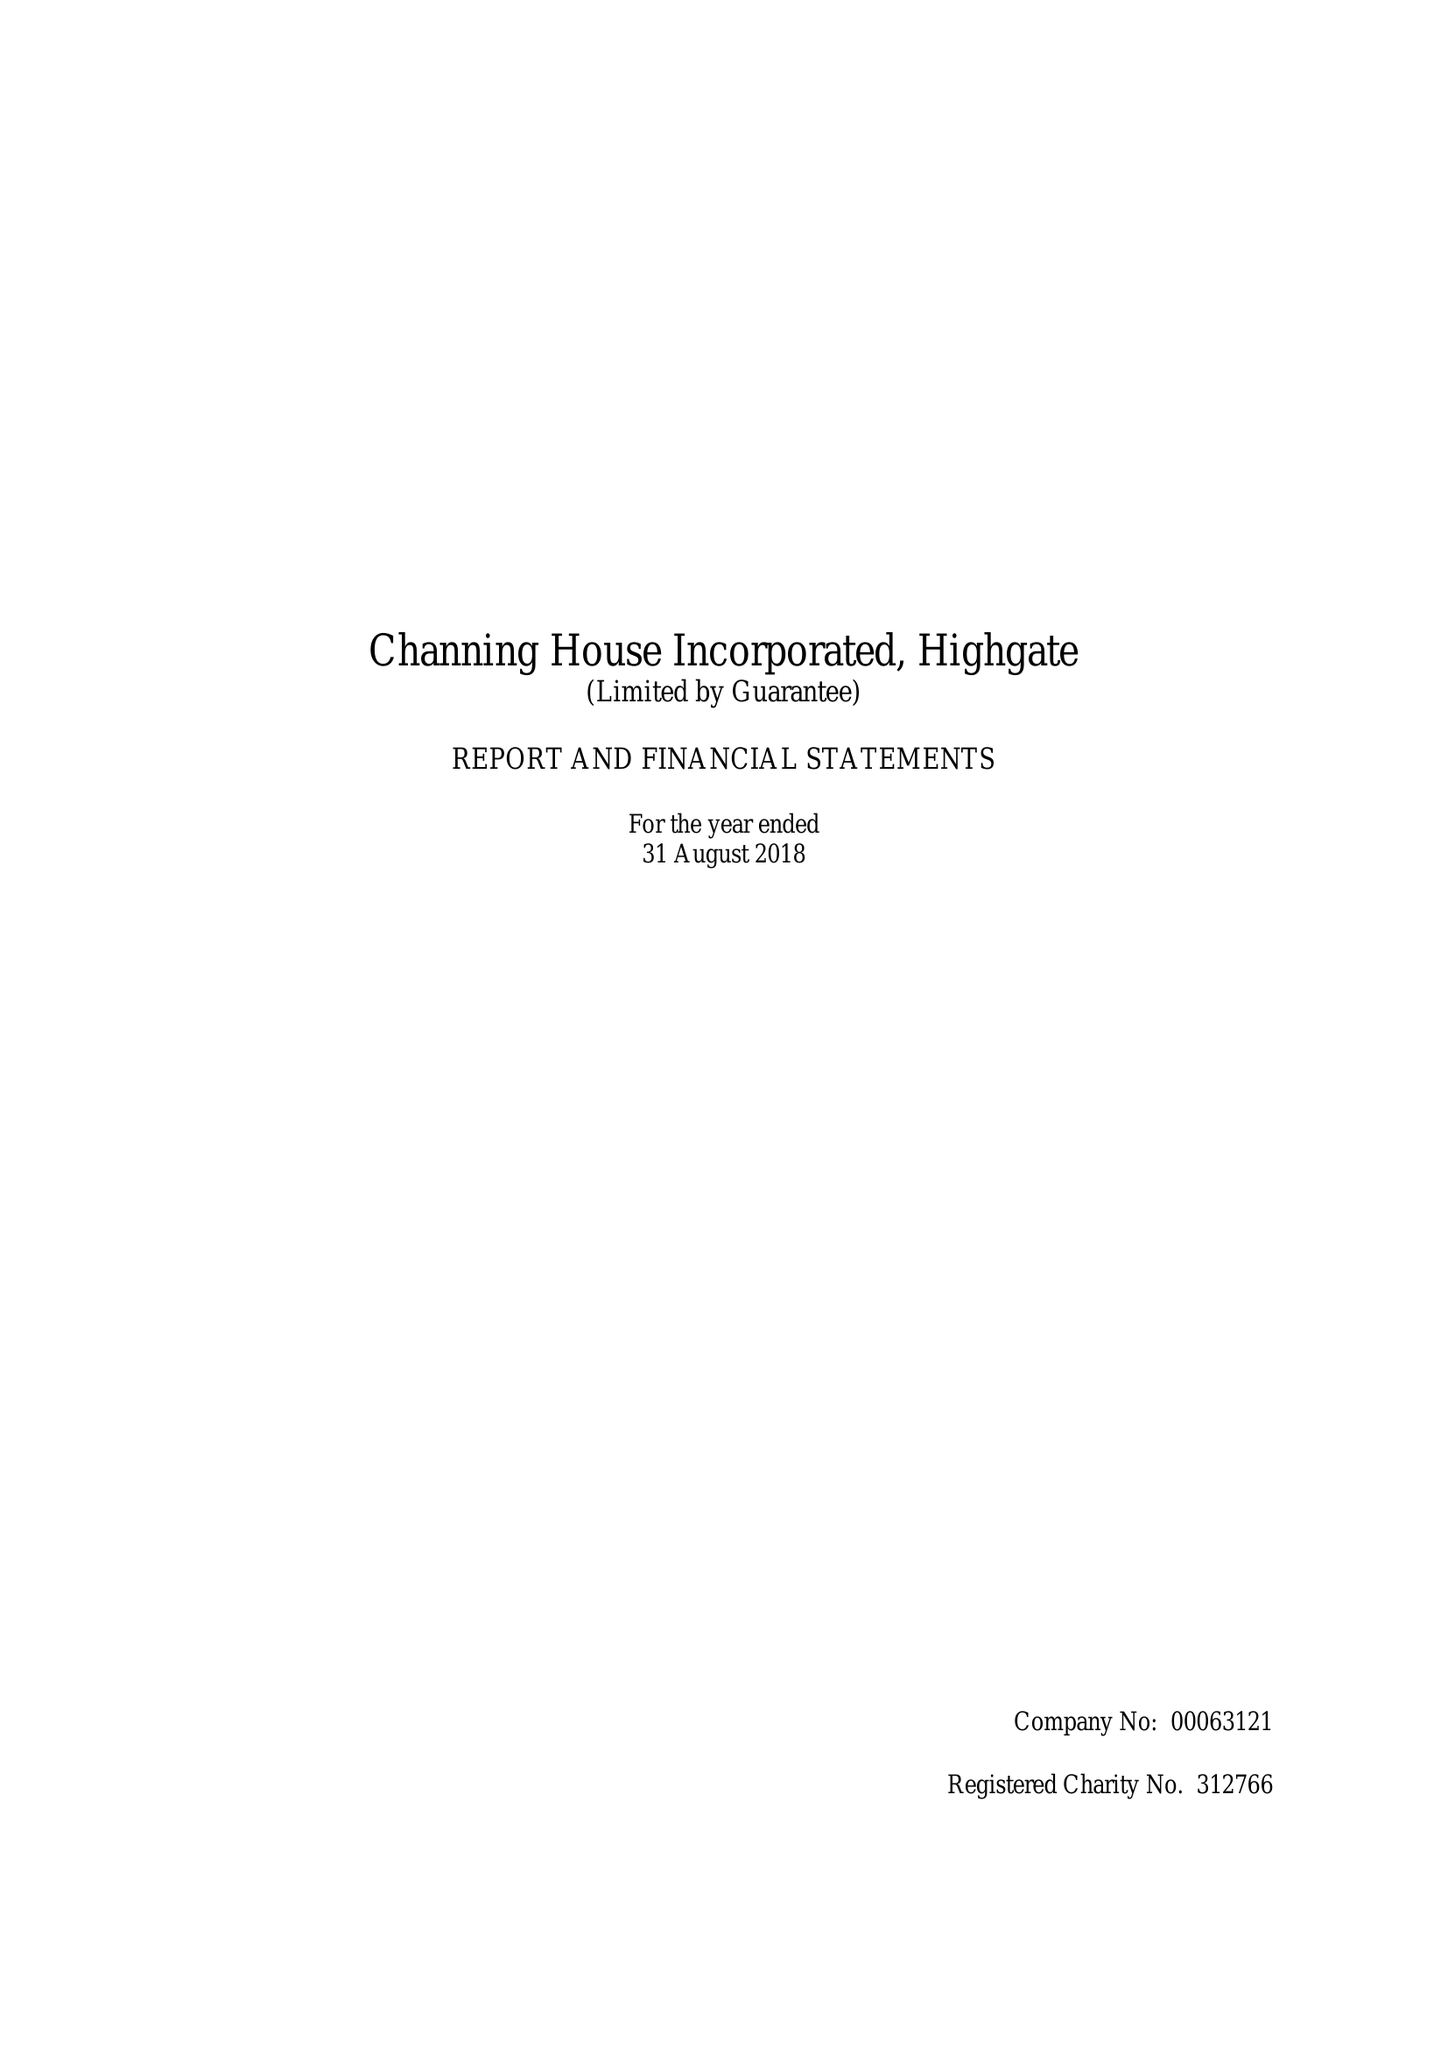What is the value for the address__street_line?
Answer the question using a single word or phrase. HIGHGATE HILL 